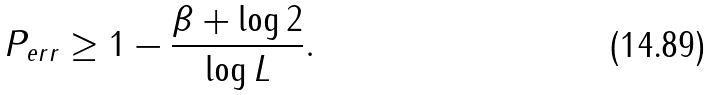<formula> <loc_0><loc_0><loc_500><loc_500>P _ { e r r } \geq 1 - \frac { \beta + \log 2 } { \log L } .</formula> 